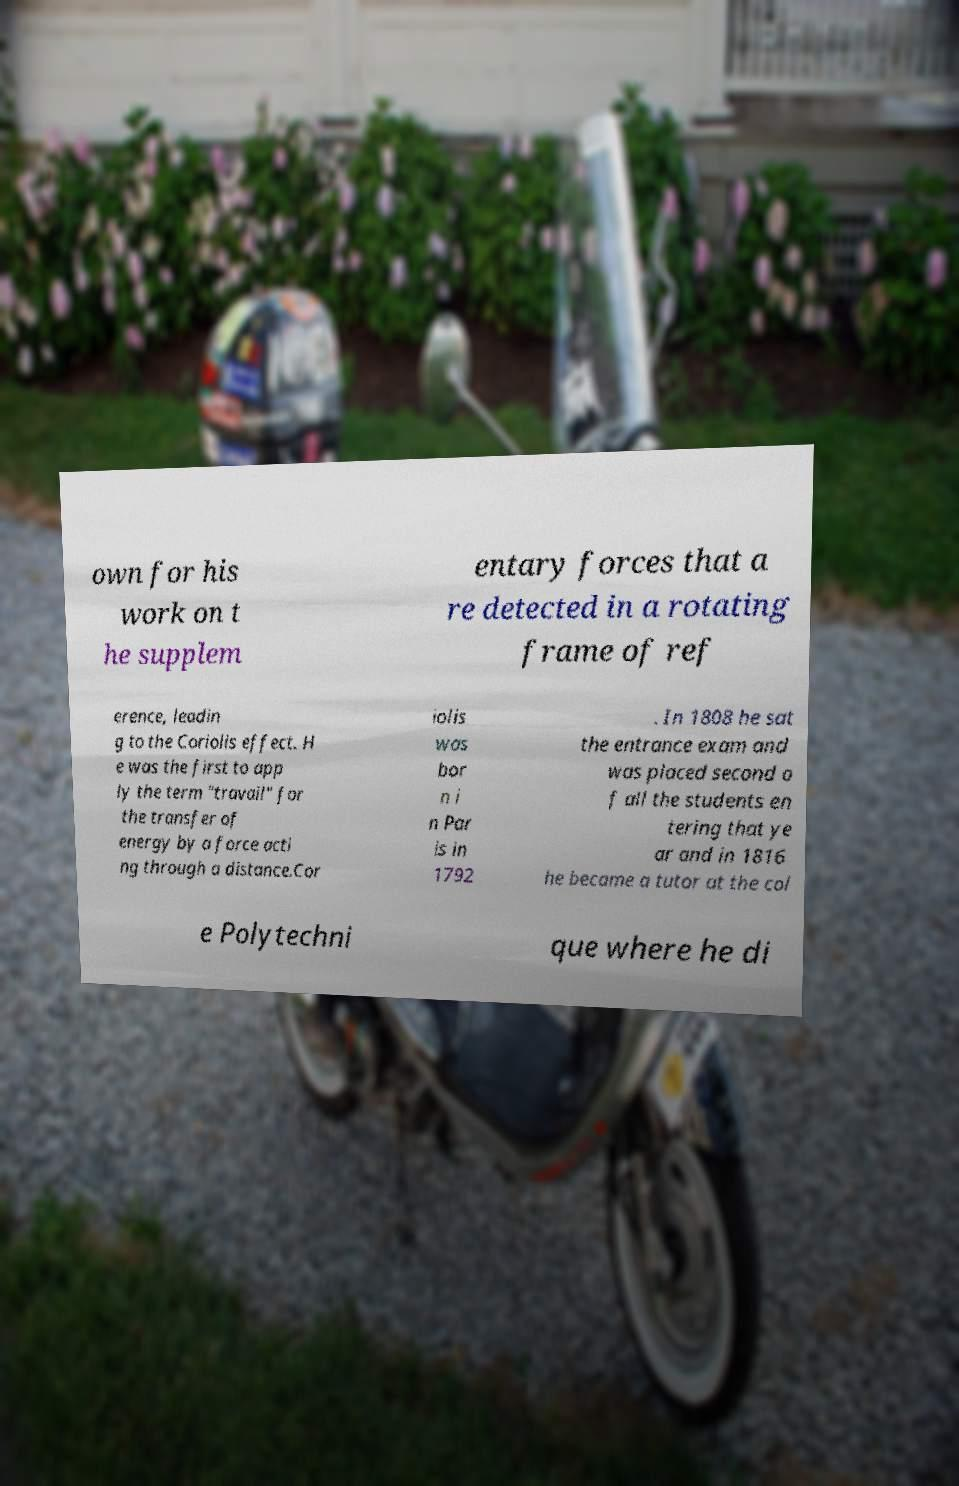For documentation purposes, I need the text within this image transcribed. Could you provide that? own for his work on t he supplem entary forces that a re detected in a rotating frame of ref erence, leadin g to the Coriolis effect. H e was the first to app ly the term "travail" for the transfer of energy by a force acti ng through a distance.Cor iolis was bor n i n Par is in 1792 . In 1808 he sat the entrance exam and was placed second o f all the students en tering that ye ar and in 1816 he became a tutor at the col e Polytechni que where he di 